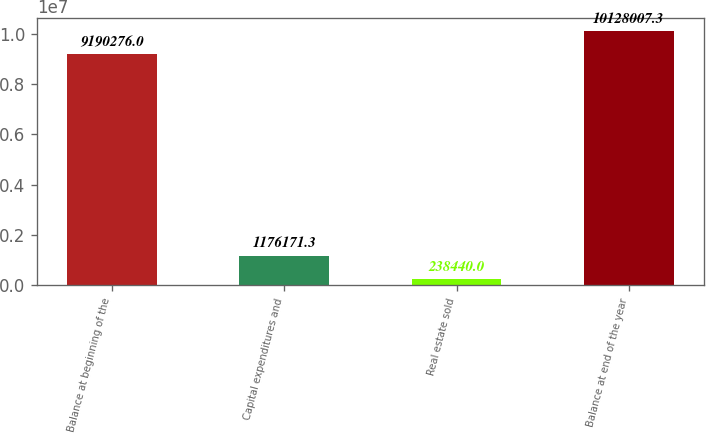Convert chart to OTSL. <chart><loc_0><loc_0><loc_500><loc_500><bar_chart><fcel>Balance at beginning of the<fcel>Capital expenditures and<fcel>Real estate sold<fcel>Balance at end of the year<nl><fcel>9.19028e+06<fcel>1.17617e+06<fcel>238440<fcel>1.0128e+07<nl></chart> 